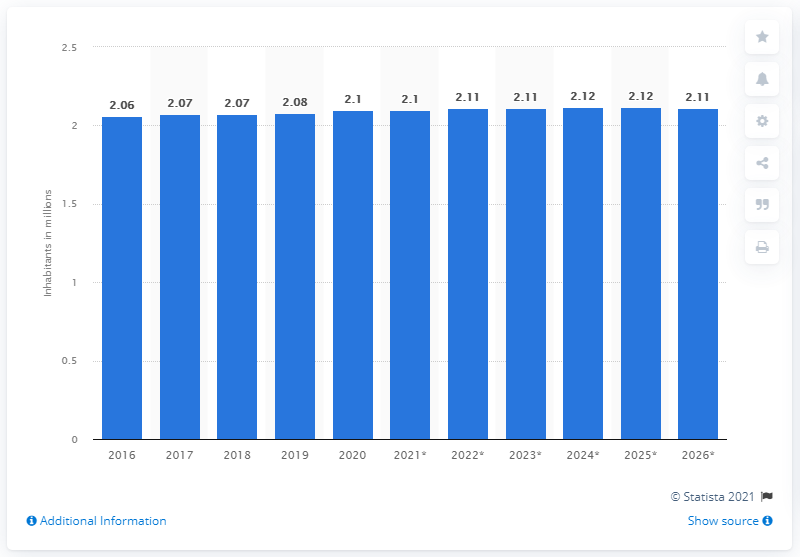Mention a couple of crucial points in this snapshot. In 2020, the population of Slovenia reached 2.1 million. In 2020, the population of Slovenia reached 2.1 million. In 2020, the population of Slovenia was 2.11 million. 